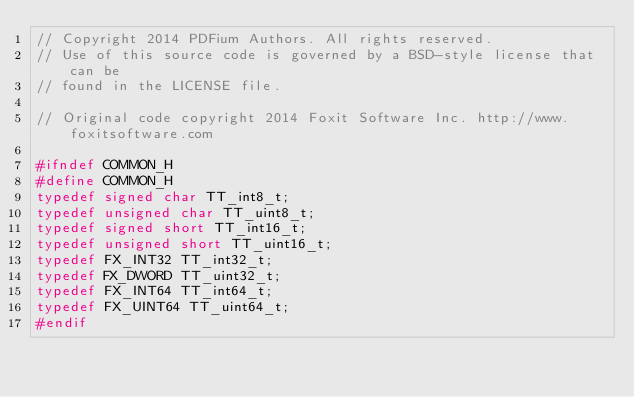<code> <loc_0><loc_0><loc_500><loc_500><_C_>// Copyright 2014 PDFium Authors. All rights reserved.
// Use of this source code is governed by a BSD-style license that can be
// found in the LICENSE file.
 
// Original code copyright 2014 Foxit Software Inc. http://www.foxitsoftware.com

#ifndef COMMON_H
#define COMMON_H
typedef signed char TT_int8_t;
typedef unsigned char TT_uint8_t;
typedef signed short TT_int16_t;
typedef unsigned short TT_uint16_t;
typedef FX_INT32 TT_int32_t;
typedef FX_DWORD TT_uint32_t;
typedef FX_INT64 TT_int64_t;
typedef FX_UINT64 TT_uint64_t;
#endif
</code> 